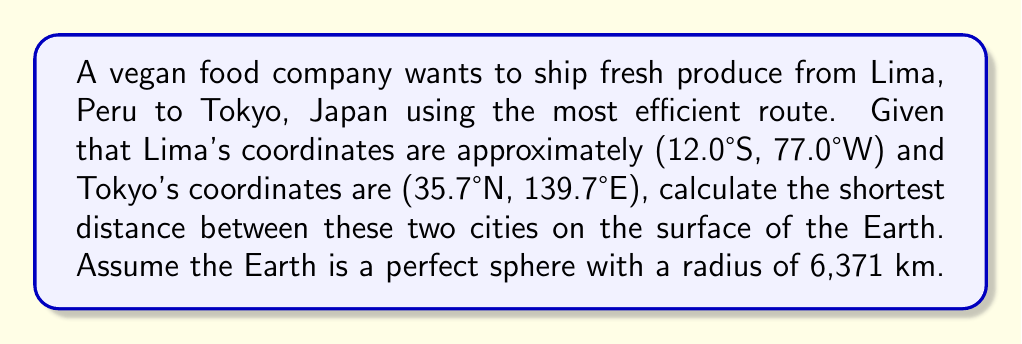Teach me how to tackle this problem. To find the shortest distance between two points on a sphere, we need to calculate the great-circle distance using the haversine formula. Here's how to solve this problem step by step:

1. Convert the latitude and longitude coordinates from degrees to radians:
   Lima: $\phi_1 = -12.0° \times \frac{\pi}{180} = -0.2094$ rad, $\lambda_1 = -77.0° \times \frac{\pi}{180} = -1.3439$ rad
   Tokyo: $\phi_2 = 35.7° \times \frac{\pi}{180} = 0.6230$ rad, $\lambda_2 = 139.7° \times \frac{\pi}{180} = 2.4383$ rad

2. Calculate the difference in longitude:
   $\Delta\lambda = \lambda_2 - \lambda_1 = 2.4383 - (-1.3439) = 3.7822$ rad

3. Apply the haversine formula:
   $$a = \sin^2\left(\frac{\Delta\phi}{2}\right) + \cos\phi_1 \cos\phi_2 \sin^2\left(\frac{\Delta\lambda}{2}\right)$$
   
   Where $\Delta\phi = \phi_2 - \phi_1 = 0.6230 - (-0.2094) = 0.8324$ rad

   $$a = \sin^2\left(\frac{0.8324}{2}\right) + \cos(-0.2094) \cos(0.6230) \sin^2\left(\frac{3.7822}{2}\right) = 0.6909$$

4. Calculate the central angle:
   $$c = 2 \arctan2(\sqrt{a}, \sqrt{1-a}) = 2 \arctan2(\sqrt{0.6909}, \sqrt{1-0.6909}) = 1.8453$$ rad

5. Finally, calculate the distance:
   $$d = R \times c = 6371 \times 1.8453 = 11,755.8$$ km

[asy]
import geometry;

size(200);
pair O=(0,0);
real R=5;
draw(circle(O,R));

pair lima = R*dir(192);
pair tokyo = R*dir(60);

draw(O--lima,dashed);
draw(O--tokyo,dashed);
draw(lima--tokyo,red);

dot("Lima",lima,SW);
dot("Tokyo",tokyo,NE);
label("Earth",O);
[/asy]
Answer: 11,755.8 km 